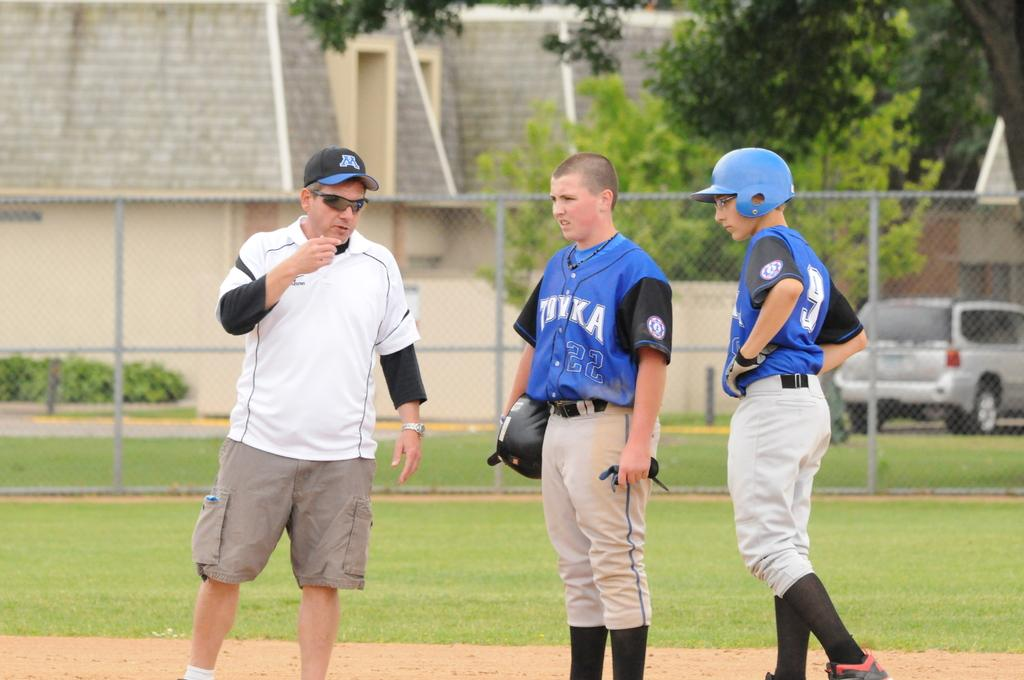<image>
Summarize the visual content of the image. A boy with a 22 jersey talks to his coach with his teammate. 